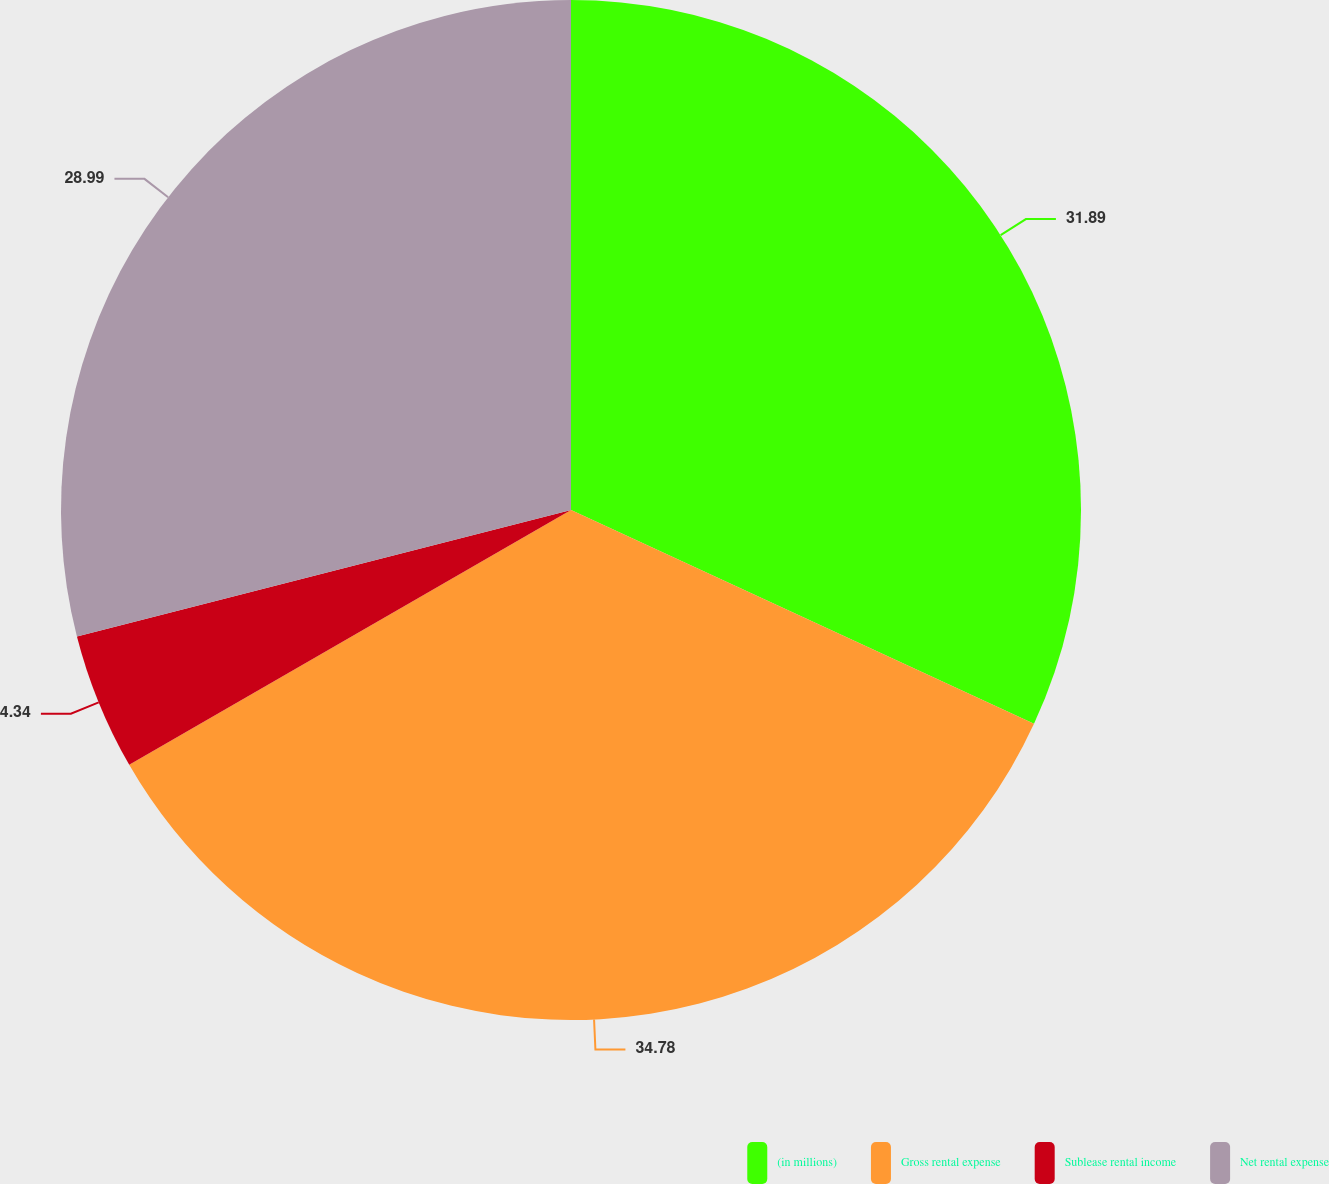Convert chart. <chart><loc_0><loc_0><loc_500><loc_500><pie_chart><fcel>(in millions)<fcel>Gross rental expense<fcel>Sublease rental income<fcel>Net rental expense<nl><fcel>31.89%<fcel>34.79%<fcel>4.34%<fcel>28.99%<nl></chart> 